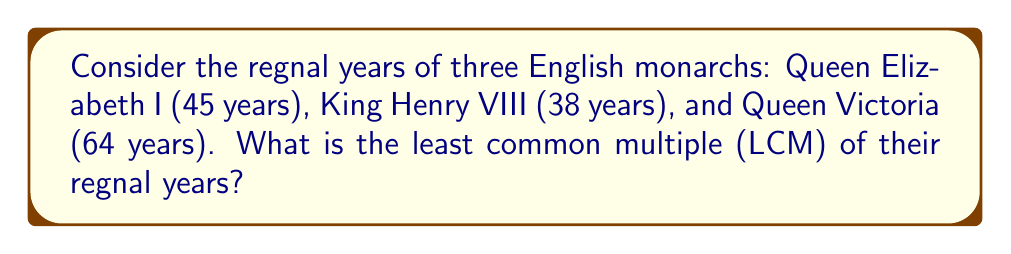Help me with this question. To find the least common multiple (LCM) of 45, 38, and 64, we'll follow these steps:

1. First, let's find the prime factorization of each number:
   
   45 = $3^2 \times 5$
   38 = $2 \times 19$
   64 = $2^6$

2. The LCM will include the highest power of each prime factor from these factorizations:

   LCM = $2^6 \times 3^2 \times 5 \times 19$

3. Now, let's calculate this:
   
   $2^6 = 64$
   $3^2 = 9$
   $5 = 5$
   $19 = 19$

   $64 \times 9 \times 5 \times 19 = 54,720$

Therefore, the least common multiple of the regnal years of Queen Elizabeth I, King Henry VIII, and Queen Victoria is 54,720 years.
Answer: 54,720 years 